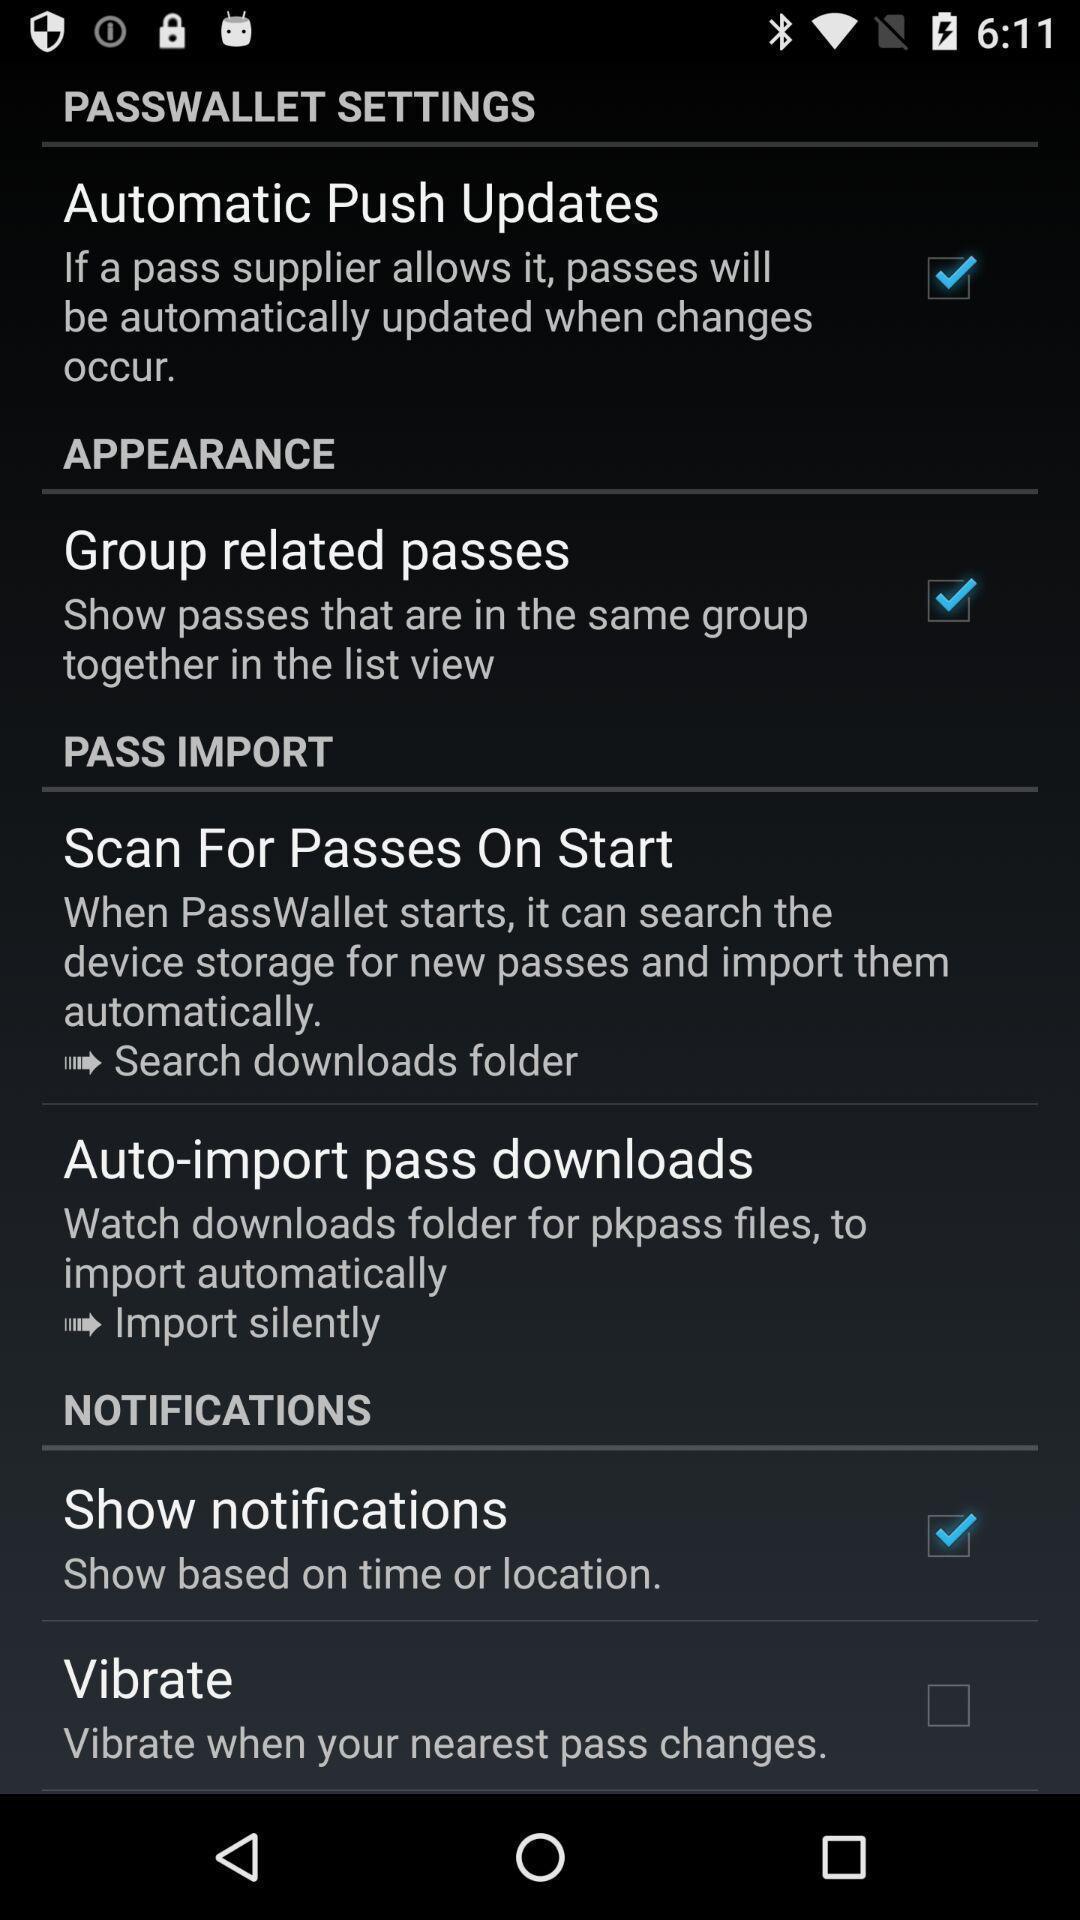Give me a narrative description of this picture. Settings page in an airlines app. 